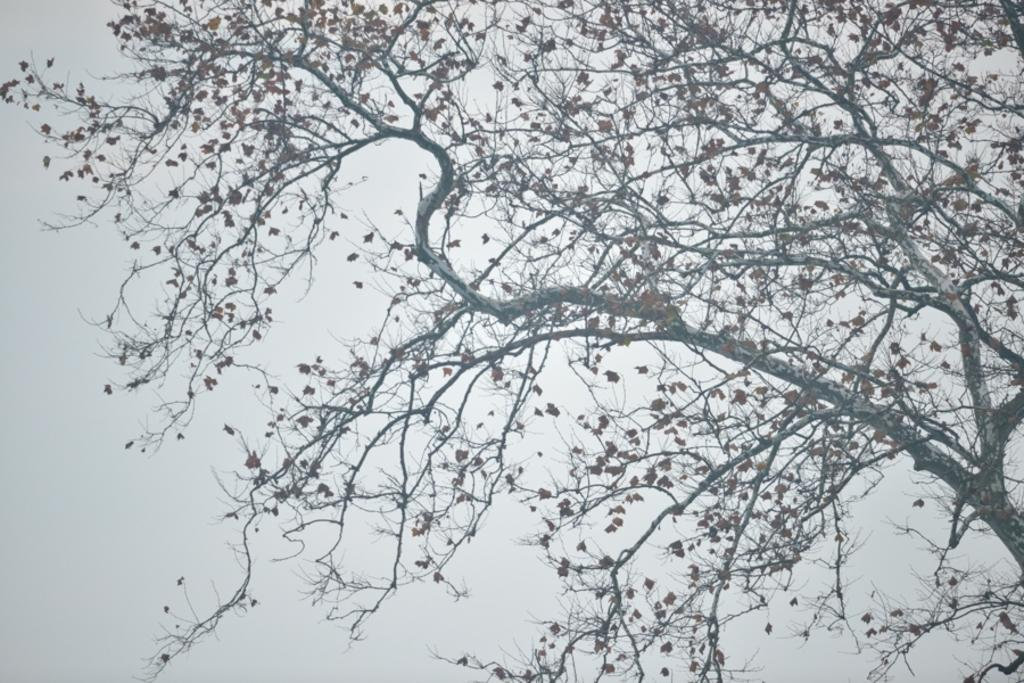What type of plant can be seen in the image? There is a tree in the image. What part of the tree is visible in the image? Leaves are visible in the image. What else can be seen in the image besides the tree? The sky is visible in the image. What type of toys can be seen in the image? There are no toys present in the image. What is the purpose of the tree in the image? The purpose of the tree in the image cannot be determined from the image alone, as it is a natural object and does not have a specific purpose within the context of the image. 